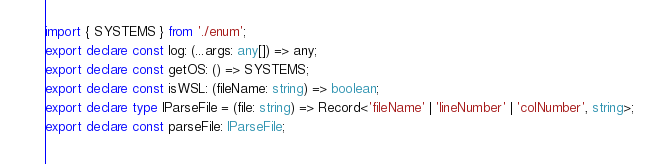<code> <loc_0><loc_0><loc_500><loc_500><_TypeScript_>import { SYSTEMS } from './enum';
export declare const log: (...args: any[]) => any;
export declare const getOS: () => SYSTEMS;
export declare const isWSL: (fileName: string) => boolean;
export declare type IParseFile = (file: string) => Record<'fileName' | 'lineNumber' | 'colNumber', string>;
export declare const parseFile: IParseFile;
</code> 